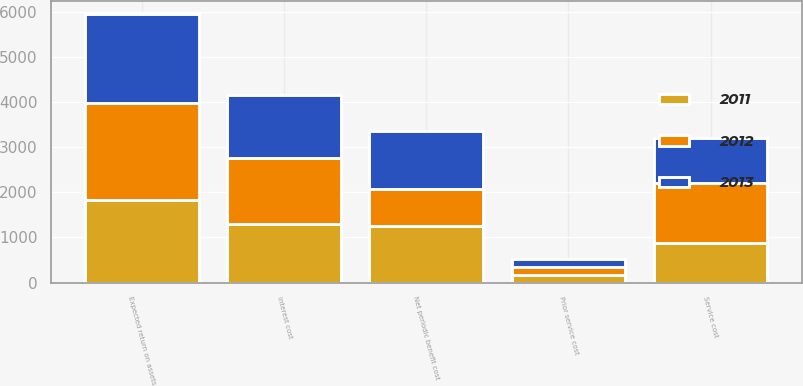<chart> <loc_0><loc_0><loc_500><loc_500><stacked_bar_chart><ecel><fcel>Service cost<fcel>Interest cost<fcel>Expected return on assets<fcel>Prior service cost<fcel>Net periodic benefit cost<nl><fcel>2012<fcel>1349<fcel>1449<fcel>2147<fcel>172<fcel>823<nl><fcel>2013<fcel>998<fcel>1410<fcel>1970<fcel>173<fcel>1280<nl><fcel>2011<fcel>870<fcel>1309<fcel>1835<fcel>171<fcel>1251<nl></chart> 